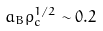Convert formula to latex. <formula><loc_0><loc_0><loc_500><loc_500>a _ { B } \rho _ { c } ^ { 1 / 2 } \sim 0 . 2</formula> 